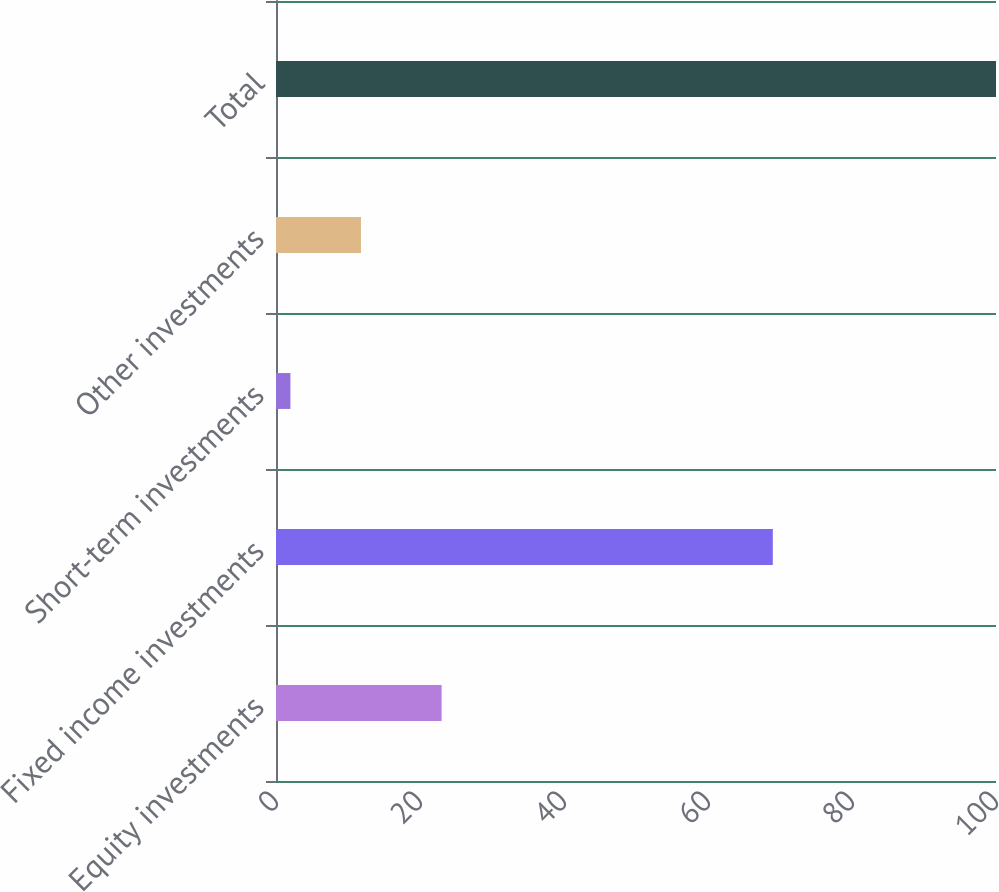<chart> <loc_0><loc_0><loc_500><loc_500><bar_chart><fcel>Equity investments<fcel>Fixed income investments<fcel>Short-term investments<fcel>Other investments<fcel>Total<nl><fcel>23<fcel>69<fcel>2<fcel>11.8<fcel>100<nl></chart> 